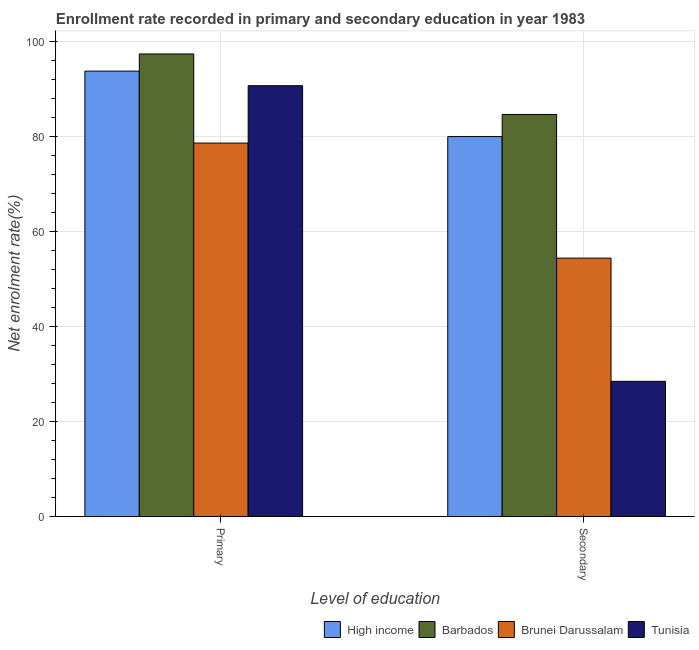How many different coloured bars are there?
Ensure brevity in your answer.  4. How many groups of bars are there?
Provide a short and direct response. 2. Are the number of bars per tick equal to the number of legend labels?
Provide a short and direct response. Yes. Are the number of bars on each tick of the X-axis equal?
Your answer should be compact. Yes. What is the label of the 1st group of bars from the left?
Your answer should be very brief. Primary. What is the enrollment rate in primary education in High income?
Keep it short and to the point. 93.73. Across all countries, what is the maximum enrollment rate in secondary education?
Your answer should be compact. 84.61. Across all countries, what is the minimum enrollment rate in secondary education?
Provide a short and direct response. 28.45. In which country was the enrollment rate in primary education maximum?
Give a very brief answer. Barbados. In which country was the enrollment rate in secondary education minimum?
Provide a succinct answer. Tunisia. What is the total enrollment rate in secondary education in the graph?
Give a very brief answer. 247.39. What is the difference between the enrollment rate in secondary education in High income and that in Tunisia?
Your answer should be very brief. 51.51. What is the difference between the enrollment rate in secondary education in Barbados and the enrollment rate in primary education in Brunei Darussalam?
Your response must be concise. 6.03. What is the average enrollment rate in secondary education per country?
Keep it short and to the point. 61.85. What is the difference between the enrollment rate in secondary education and enrollment rate in primary education in Brunei Darussalam?
Your answer should be very brief. -24.21. In how many countries, is the enrollment rate in primary education greater than 64 %?
Offer a very short reply. 4. What is the ratio of the enrollment rate in primary education in High income to that in Tunisia?
Provide a short and direct response. 1.03. What does the 1st bar from the left in Secondary represents?
Your response must be concise. High income. What does the 3rd bar from the right in Secondary represents?
Offer a terse response. Barbados. Are all the bars in the graph horizontal?
Offer a very short reply. No. How many countries are there in the graph?
Keep it short and to the point. 4. What is the difference between two consecutive major ticks on the Y-axis?
Your answer should be very brief. 20. Where does the legend appear in the graph?
Make the answer very short. Bottom right. What is the title of the graph?
Make the answer very short. Enrollment rate recorded in primary and secondary education in year 1983. Does "Cayman Islands" appear as one of the legend labels in the graph?
Your answer should be very brief. No. What is the label or title of the X-axis?
Provide a short and direct response. Level of education. What is the label or title of the Y-axis?
Make the answer very short. Net enrolment rate(%). What is the Net enrolment rate(%) in High income in Primary?
Offer a terse response. 93.73. What is the Net enrolment rate(%) in Barbados in Primary?
Make the answer very short. 97.34. What is the Net enrolment rate(%) of Brunei Darussalam in Primary?
Offer a terse response. 78.58. What is the Net enrolment rate(%) of Tunisia in Primary?
Make the answer very short. 90.66. What is the Net enrolment rate(%) of High income in Secondary?
Give a very brief answer. 79.95. What is the Net enrolment rate(%) in Barbados in Secondary?
Offer a very short reply. 84.61. What is the Net enrolment rate(%) in Brunei Darussalam in Secondary?
Make the answer very short. 54.38. What is the Net enrolment rate(%) of Tunisia in Secondary?
Offer a very short reply. 28.45. Across all Level of education, what is the maximum Net enrolment rate(%) of High income?
Your answer should be compact. 93.73. Across all Level of education, what is the maximum Net enrolment rate(%) in Barbados?
Offer a very short reply. 97.34. Across all Level of education, what is the maximum Net enrolment rate(%) in Brunei Darussalam?
Keep it short and to the point. 78.58. Across all Level of education, what is the maximum Net enrolment rate(%) of Tunisia?
Your answer should be very brief. 90.66. Across all Level of education, what is the minimum Net enrolment rate(%) in High income?
Your response must be concise. 79.95. Across all Level of education, what is the minimum Net enrolment rate(%) of Barbados?
Offer a very short reply. 84.61. Across all Level of education, what is the minimum Net enrolment rate(%) in Brunei Darussalam?
Your answer should be compact. 54.38. Across all Level of education, what is the minimum Net enrolment rate(%) in Tunisia?
Your answer should be compact. 28.45. What is the total Net enrolment rate(%) of High income in the graph?
Your answer should be very brief. 173.68. What is the total Net enrolment rate(%) of Barbados in the graph?
Provide a short and direct response. 181.95. What is the total Net enrolment rate(%) in Brunei Darussalam in the graph?
Your response must be concise. 132.96. What is the total Net enrolment rate(%) of Tunisia in the graph?
Ensure brevity in your answer.  119.11. What is the difference between the Net enrolment rate(%) of High income in Primary and that in Secondary?
Provide a short and direct response. 13.78. What is the difference between the Net enrolment rate(%) of Barbados in Primary and that in Secondary?
Make the answer very short. 12.73. What is the difference between the Net enrolment rate(%) in Brunei Darussalam in Primary and that in Secondary?
Provide a succinct answer. 24.21. What is the difference between the Net enrolment rate(%) in Tunisia in Primary and that in Secondary?
Ensure brevity in your answer.  62.21. What is the difference between the Net enrolment rate(%) in High income in Primary and the Net enrolment rate(%) in Barbados in Secondary?
Your response must be concise. 9.12. What is the difference between the Net enrolment rate(%) of High income in Primary and the Net enrolment rate(%) of Brunei Darussalam in Secondary?
Provide a succinct answer. 39.35. What is the difference between the Net enrolment rate(%) in High income in Primary and the Net enrolment rate(%) in Tunisia in Secondary?
Ensure brevity in your answer.  65.28. What is the difference between the Net enrolment rate(%) of Barbados in Primary and the Net enrolment rate(%) of Brunei Darussalam in Secondary?
Offer a terse response. 42.96. What is the difference between the Net enrolment rate(%) in Barbados in Primary and the Net enrolment rate(%) in Tunisia in Secondary?
Provide a short and direct response. 68.89. What is the difference between the Net enrolment rate(%) in Brunei Darussalam in Primary and the Net enrolment rate(%) in Tunisia in Secondary?
Provide a succinct answer. 50.13. What is the average Net enrolment rate(%) of High income per Level of education?
Offer a very short reply. 86.84. What is the average Net enrolment rate(%) in Barbados per Level of education?
Provide a succinct answer. 90.97. What is the average Net enrolment rate(%) of Brunei Darussalam per Level of education?
Your answer should be very brief. 66.48. What is the average Net enrolment rate(%) in Tunisia per Level of education?
Your answer should be compact. 59.55. What is the difference between the Net enrolment rate(%) of High income and Net enrolment rate(%) of Barbados in Primary?
Give a very brief answer. -3.61. What is the difference between the Net enrolment rate(%) of High income and Net enrolment rate(%) of Brunei Darussalam in Primary?
Your answer should be very brief. 15.15. What is the difference between the Net enrolment rate(%) in High income and Net enrolment rate(%) in Tunisia in Primary?
Make the answer very short. 3.07. What is the difference between the Net enrolment rate(%) of Barbados and Net enrolment rate(%) of Brunei Darussalam in Primary?
Make the answer very short. 18.76. What is the difference between the Net enrolment rate(%) in Barbados and Net enrolment rate(%) in Tunisia in Primary?
Provide a succinct answer. 6.68. What is the difference between the Net enrolment rate(%) in Brunei Darussalam and Net enrolment rate(%) in Tunisia in Primary?
Make the answer very short. -12.08. What is the difference between the Net enrolment rate(%) of High income and Net enrolment rate(%) of Barbados in Secondary?
Offer a very short reply. -4.65. What is the difference between the Net enrolment rate(%) of High income and Net enrolment rate(%) of Brunei Darussalam in Secondary?
Keep it short and to the point. 25.58. What is the difference between the Net enrolment rate(%) of High income and Net enrolment rate(%) of Tunisia in Secondary?
Ensure brevity in your answer.  51.51. What is the difference between the Net enrolment rate(%) of Barbados and Net enrolment rate(%) of Brunei Darussalam in Secondary?
Give a very brief answer. 30.23. What is the difference between the Net enrolment rate(%) of Barbados and Net enrolment rate(%) of Tunisia in Secondary?
Make the answer very short. 56.16. What is the difference between the Net enrolment rate(%) of Brunei Darussalam and Net enrolment rate(%) of Tunisia in Secondary?
Your response must be concise. 25.93. What is the ratio of the Net enrolment rate(%) of High income in Primary to that in Secondary?
Your answer should be compact. 1.17. What is the ratio of the Net enrolment rate(%) of Barbados in Primary to that in Secondary?
Your response must be concise. 1.15. What is the ratio of the Net enrolment rate(%) in Brunei Darussalam in Primary to that in Secondary?
Your answer should be very brief. 1.45. What is the ratio of the Net enrolment rate(%) of Tunisia in Primary to that in Secondary?
Your answer should be very brief. 3.19. What is the difference between the highest and the second highest Net enrolment rate(%) of High income?
Provide a short and direct response. 13.78. What is the difference between the highest and the second highest Net enrolment rate(%) of Barbados?
Provide a short and direct response. 12.73. What is the difference between the highest and the second highest Net enrolment rate(%) of Brunei Darussalam?
Offer a very short reply. 24.21. What is the difference between the highest and the second highest Net enrolment rate(%) in Tunisia?
Provide a short and direct response. 62.21. What is the difference between the highest and the lowest Net enrolment rate(%) of High income?
Make the answer very short. 13.78. What is the difference between the highest and the lowest Net enrolment rate(%) in Barbados?
Keep it short and to the point. 12.73. What is the difference between the highest and the lowest Net enrolment rate(%) of Brunei Darussalam?
Offer a very short reply. 24.21. What is the difference between the highest and the lowest Net enrolment rate(%) in Tunisia?
Offer a terse response. 62.21. 